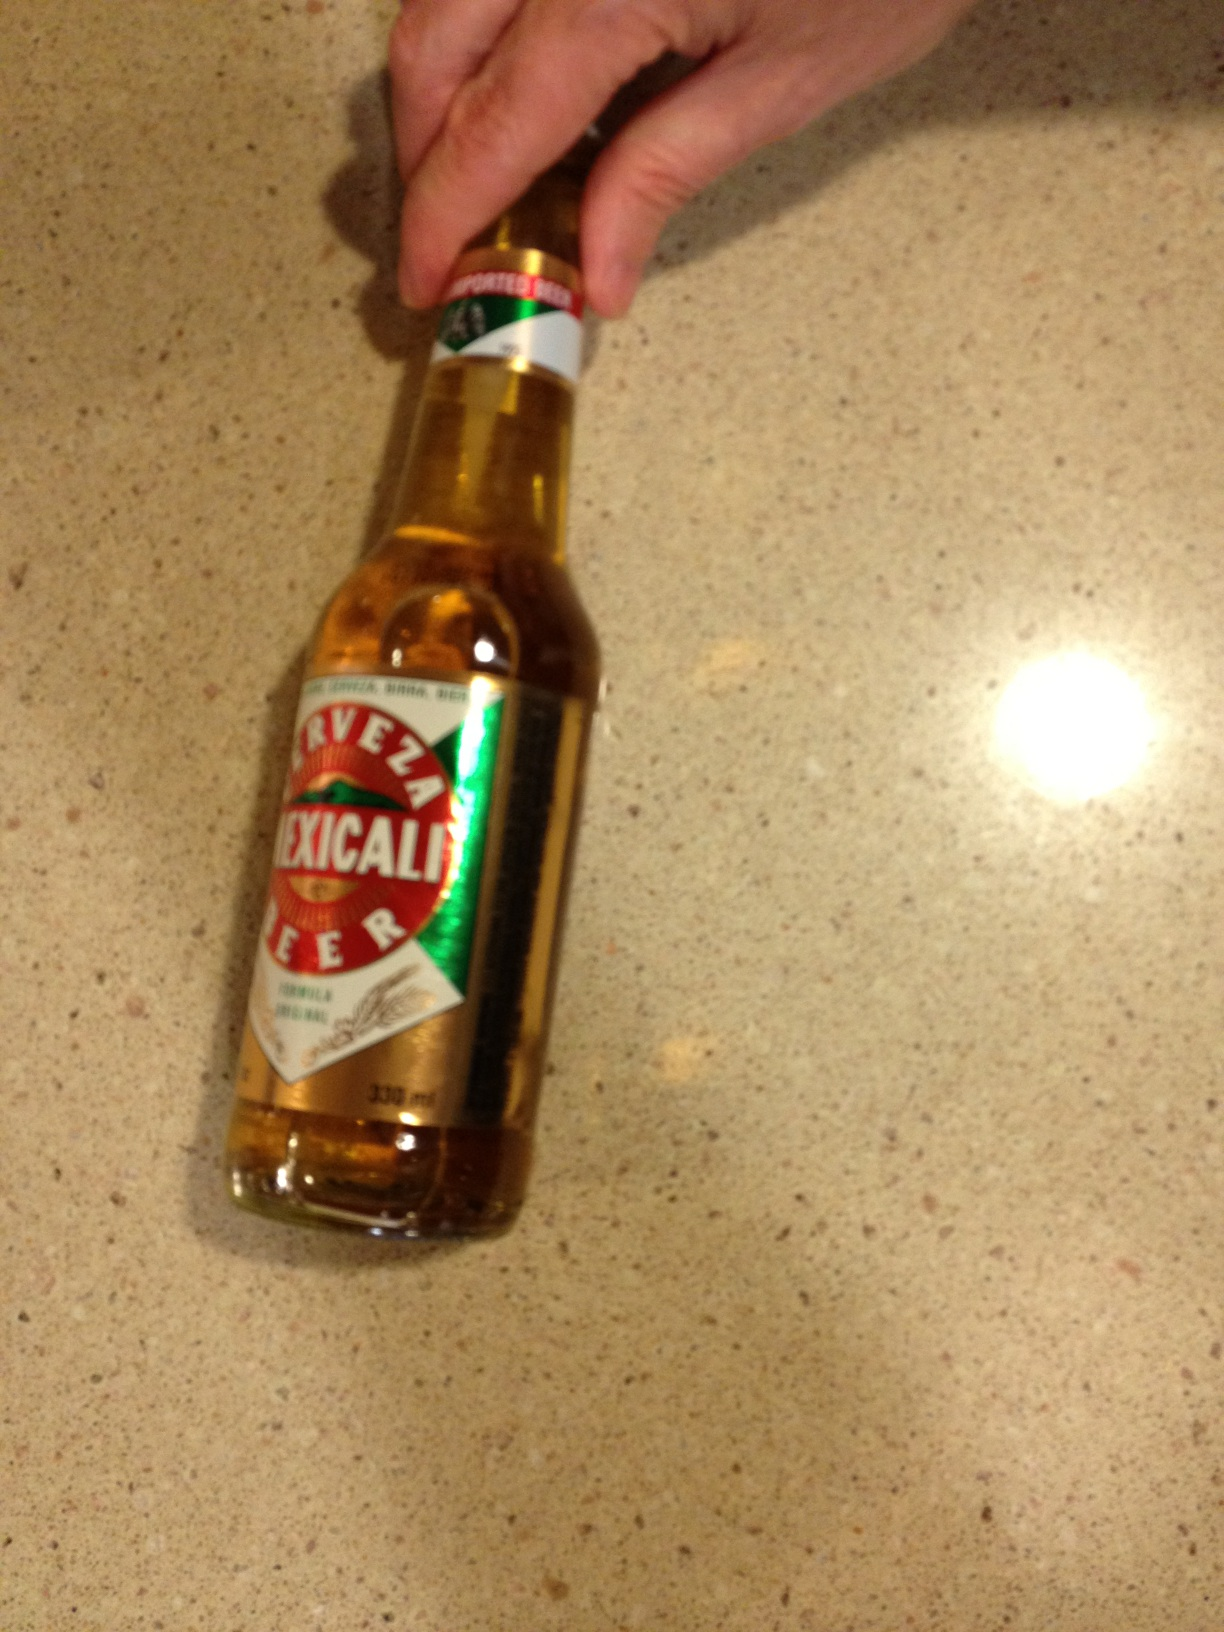Is Mexicali Beer a good pairing for any specific type of food? Indeed it is! Mexicali beer pairs splendidly with spicy dishes, such as Mexican cuisine, enhancing the flavors of tacos, enchiladas, and grilled meats with its crisp freshness. 